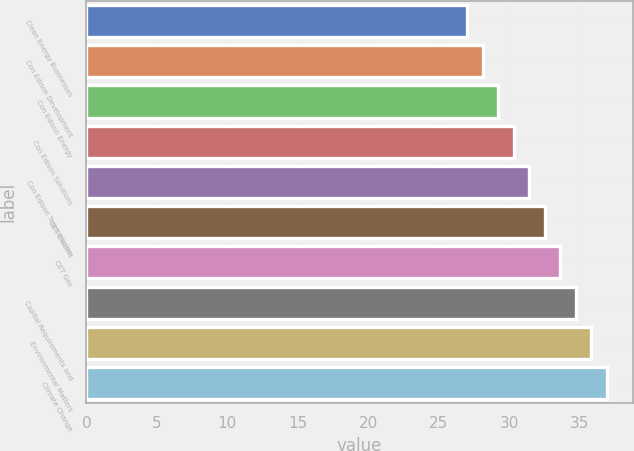Convert chart to OTSL. <chart><loc_0><loc_0><loc_500><loc_500><bar_chart><fcel>Clean Energy Businesses<fcel>Con Edison Development<fcel>Con Edison Energy<fcel>Con Edison Solutions<fcel>Con Edison Transmission<fcel>CET Electric<fcel>CET Gas<fcel>Capital Requirements and<fcel>Environmental Matters<fcel>Climate Change<nl><fcel>27<fcel>28.1<fcel>29.2<fcel>30.3<fcel>31.4<fcel>32.5<fcel>33.6<fcel>34.7<fcel>35.8<fcel>36.9<nl></chart> 